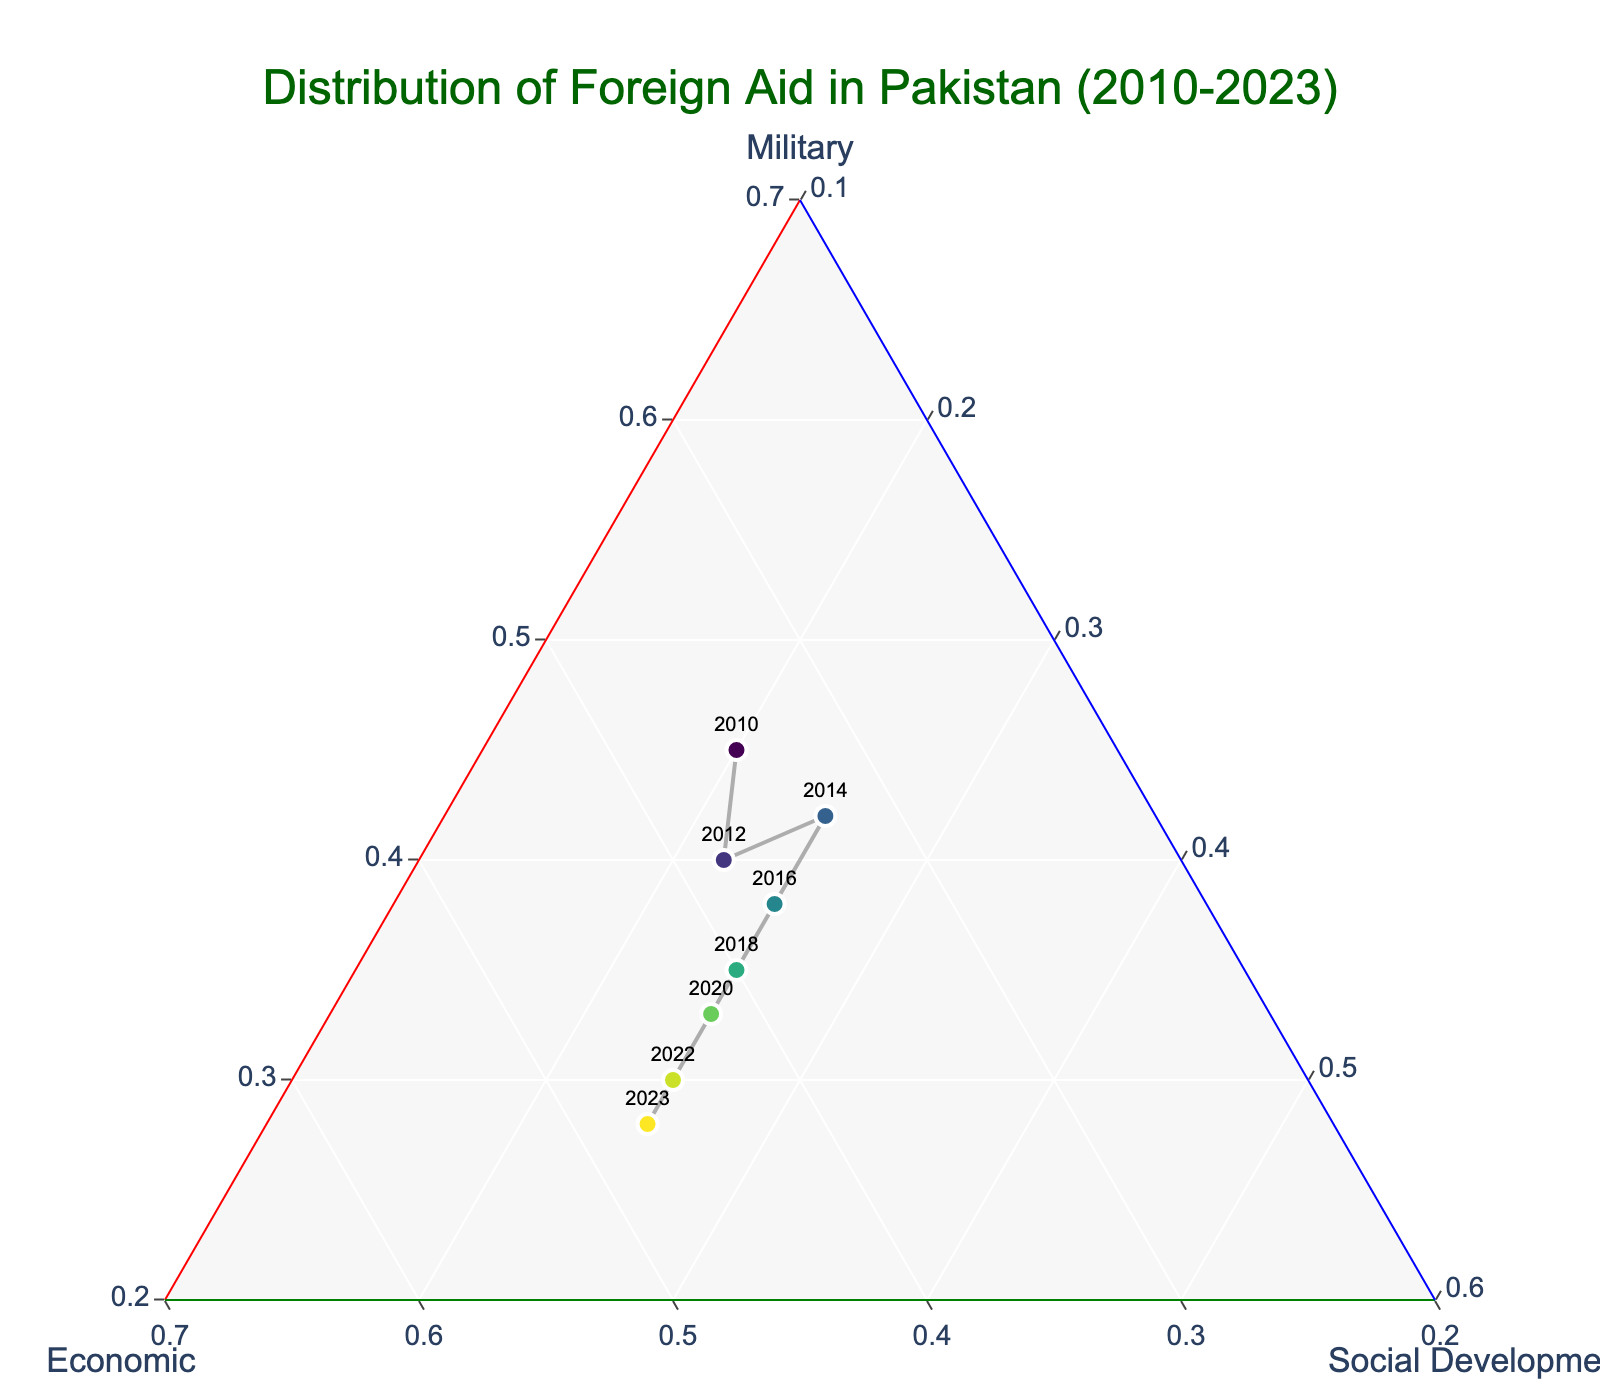What is the title of the figure? The title of the figure is displayed at the top center and provides a summary of the main topic represented by the plot.
Answer: Distribution of Foreign Aid in Pakistan (2010-2023) What are the sectors shown on the axes of the ternary plot? The sectors are indicated by the titles of the a-axis, b-axis, and c-axis. In a ternary plot, these often represent different aspects being compared.
Answer: Military, Economic, Social Development Which year had the highest proportion of economic aid? Identify the marker location on the ternary plot where the economic ratio (b) is highest. The plot may show this with a specific color or label.
Answer: 2023 In which year was the distribution of aid between military and economic sectors equal? Look for a point where the ratios of military and economic aid intersect or are closest. This can be identified by positions on the ternary plot where 'a' and 'b' are nearly equal.
Answer: 2012 Which sector has the most consistent allocation over the years? By observing the markers' positions along the axis representing each sector, determine which axis shows the least variation in the positions. This indicates consistent allocation over time.
Answer: Social Development How did the proportion of military aid change from 2010 to 2023? Compare the markers for 2010 and 2023 on the ternary plot to see the change in the military ratio ('a'). Note whether it increased or decreased and by how much.
Answer: Decreased What is the trend in the proportion of economic aid from 2010 to 2023? Observe the markers along the economic ratio ('b') over time. Trace from 2010 to 2023 to identify if there's an increasing or decreasing pattern.
Answer: Increasing Which year lies closest to the centroid of the ternary plot? The centroid of a ternary plot is the point where the proportions of each axis are equal (approximately 0.33 for three axes). Determine which year's marker is closest to these coordinates.
Answer: 2018 What colors are the markers for different years? The colors of the markers are based on the year and typically follow a color scale provided in the plot, helping differentiate between years visually.
Answer: They follow a Viridis colorscale Which two years have the greatest difference in economic aid proportions? Compare the economic ratio ('b') for all years and identify the two with the largest difference. Compute the absolute differences to find the answer.
Answer: 2010 and 2023 